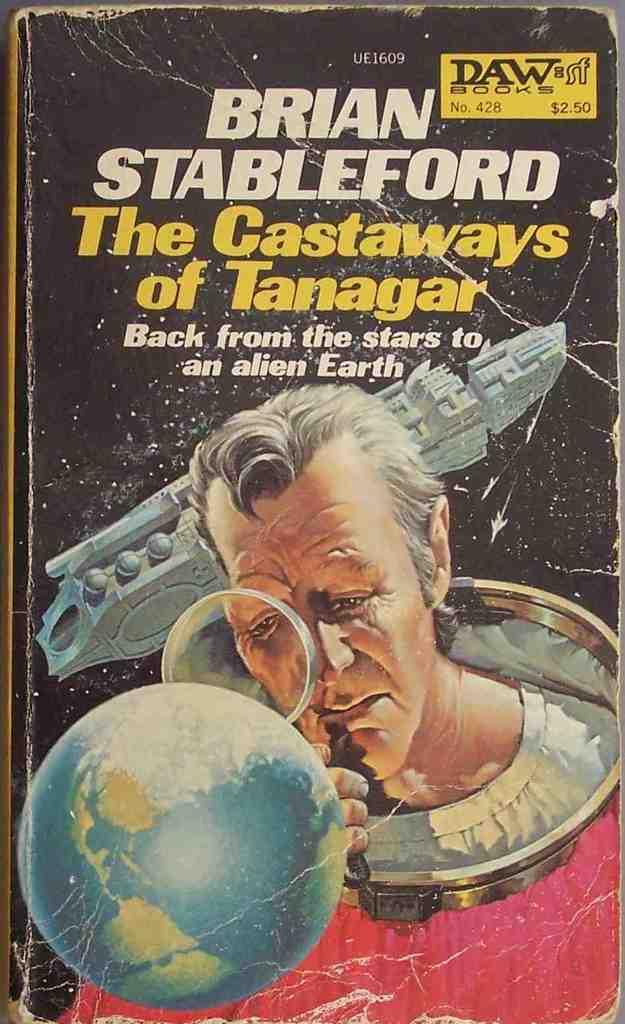How much was this book?
Offer a terse response. 2.50. 